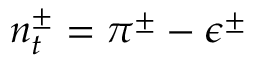<formula> <loc_0><loc_0><loc_500><loc_500>n _ { t } ^ { \pm } = \pi ^ { \pm } - \epsilon ^ { \pm }</formula> 